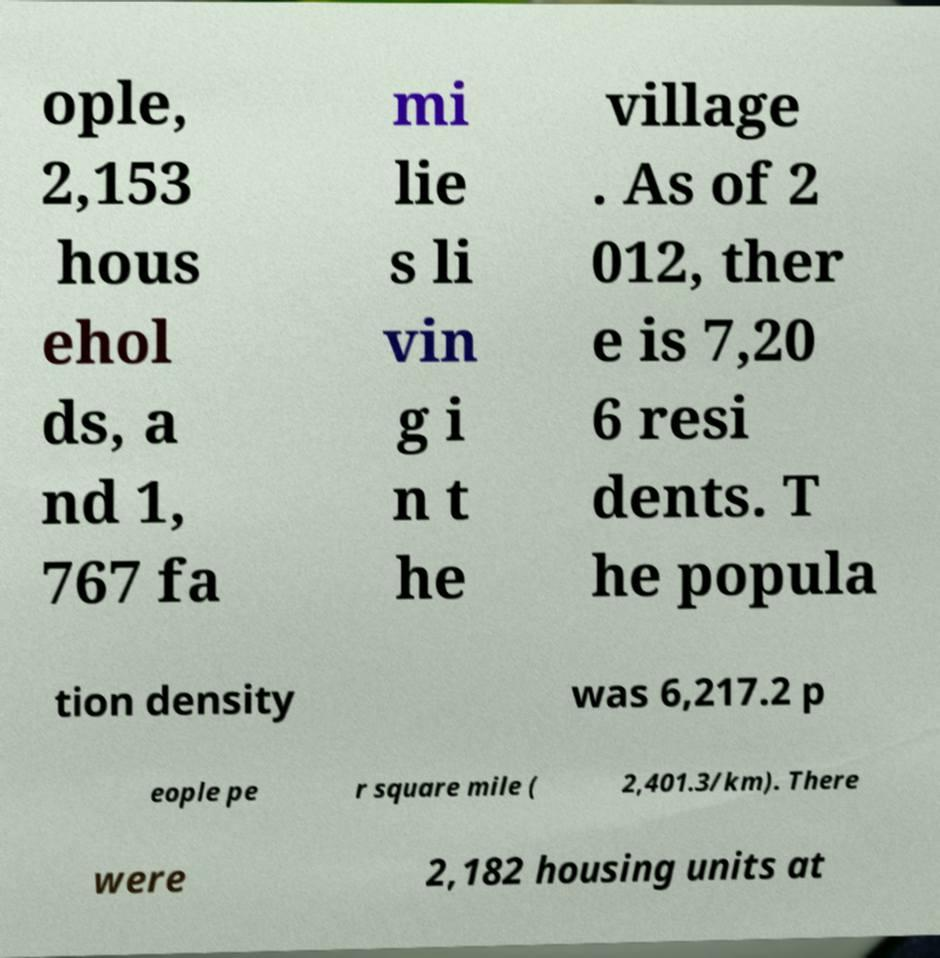There's text embedded in this image that I need extracted. Can you transcribe it verbatim? ople, 2,153 hous ehol ds, a nd 1, 767 fa mi lie s li vin g i n t he village . As of 2 012, ther e is 7,20 6 resi dents. T he popula tion density was 6,217.2 p eople pe r square mile ( 2,401.3/km). There were 2,182 housing units at 